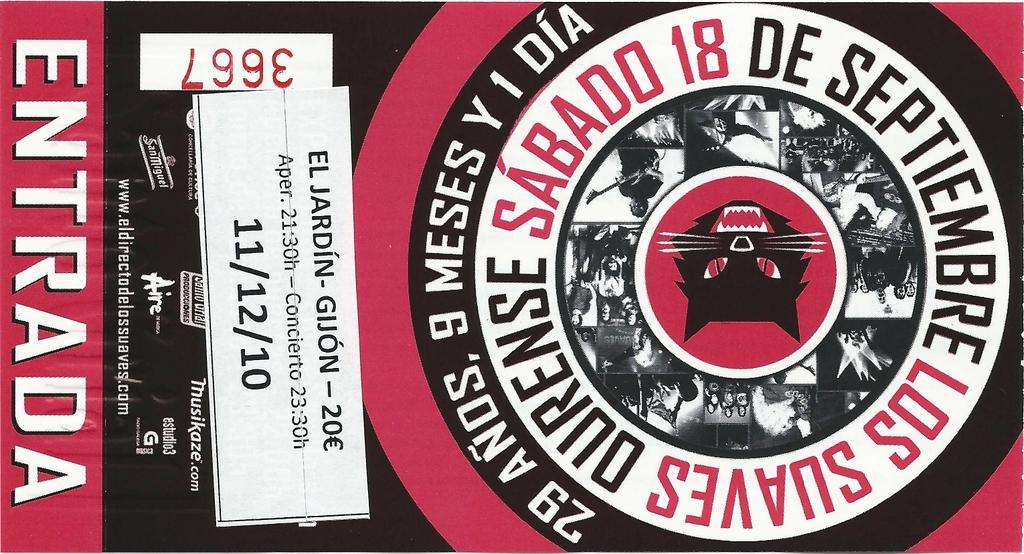<image>
Relay a brief, clear account of the picture shown. A ticket for 11/12/10 with Entrada written on the side. 